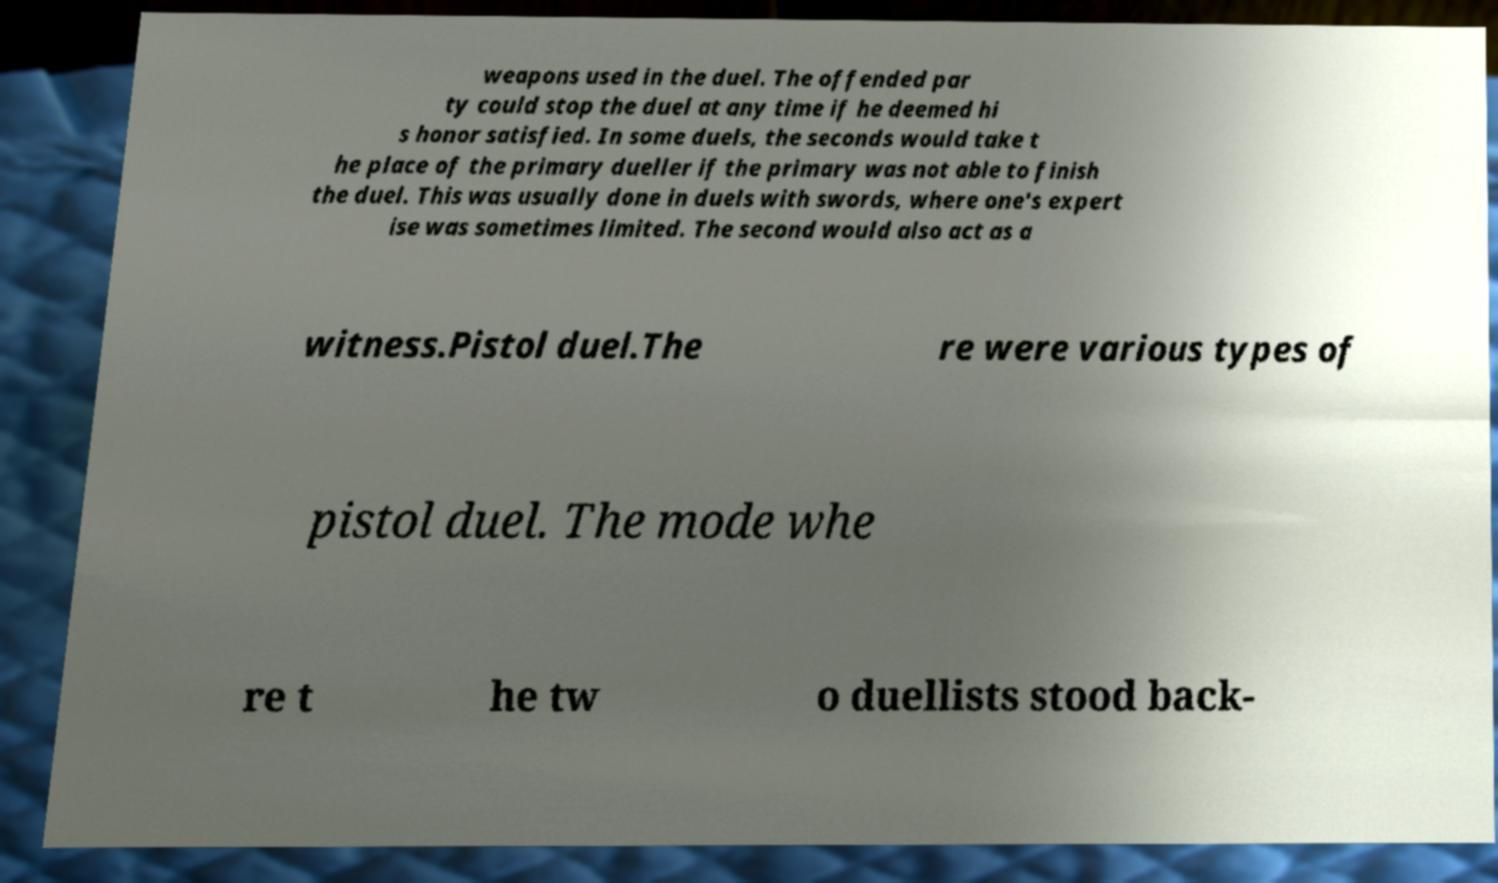Could you extract and type out the text from this image? weapons used in the duel. The offended par ty could stop the duel at any time if he deemed hi s honor satisfied. In some duels, the seconds would take t he place of the primary dueller if the primary was not able to finish the duel. This was usually done in duels with swords, where one's expert ise was sometimes limited. The second would also act as a witness.Pistol duel.The re were various types of pistol duel. The mode whe re t he tw o duellists stood back- 